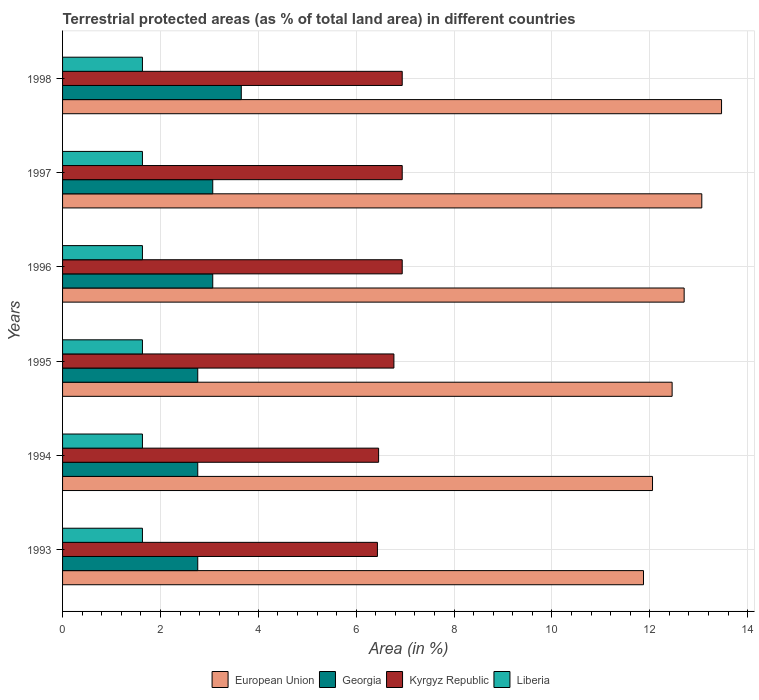How many different coloured bars are there?
Provide a succinct answer. 4. Are the number of bars per tick equal to the number of legend labels?
Offer a terse response. Yes. In how many cases, is the number of bars for a given year not equal to the number of legend labels?
Provide a succinct answer. 0. What is the percentage of terrestrial protected land in European Union in 1996?
Give a very brief answer. 12.7. Across all years, what is the maximum percentage of terrestrial protected land in Georgia?
Keep it short and to the point. 3.65. Across all years, what is the minimum percentage of terrestrial protected land in Georgia?
Your answer should be very brief. 2.76. In which year was the percentage of terrestrial protected land in Georgia maximum?
Give a very brief answer. 1998. What is the total percentage of terrestrial protected land in Kyrgyz Republic in the graph?
Provide a succinct answer. 40.49. What is the difference between the percentage of terrestrial protected land in European Union in 1996 and that in 1997?
Offer a terse response. -0.36. What is the difference between the percentage of terrestrial protected land in Liberia in 1993 and the percentage of terrestrial protected land in Kyrgyz Republic in 1997?
Ensure brevity in your answer.  -5.31. What is the average percentage of terrestrial protected land in Liberia per year?
Ensure brevity in your answer.  1.63. In the year 1996, what is the difference between the percentage of terrestrial protected land in European Union and percentage of terrestrial protected land in Liberia?
Keep it short and to the point. 11.07. In how many years, is the percentage of terrestrial protected land in Kyrgyz Republic greater than 2.4 %?
Ensure brevity in your answer.  6. What is the ratio of the percentage of terrestrial protected land in Kyrgyz Republic in 1994 to that in 1997?
Your answer should be very brief. 0.93. What is the difference between the highest and the second highest percentage of terrestrial protected land in Kyrgyz Republic?
Ensure brevity in your answer.  0. What is the difference between the highest and the lowest percentage of terrestrial protected land in Kyrgyz Republic?
Ensure brevity in your answer.  0.51. Is the sum of the percentage of terrestrial protected land in Liberia in 1994 and 1995 greater than the maximum percentage of terrestrial protected land in Georgia across all years?
Make the answer very short. No. What does the 1st bar from the top in 1998 represents?
Your answer should be very brief. Liberia. How many bars are there?
Provide a short and direct response. 24. Are all the bars in the graph horizontal?
Make the answer very short. Yes. What is the difference between two consecutive major ticks on the X-axis?
Your answer should be very brief. 2. Are the values on the major ticks of X-axis written in scientific E-notation?
Make the answer very short. No. Does the graph contain any zero values?
Your answer should be very brief. No. How many legend labels are there?
Your response must be concise. 4. What is the title of the graph?
Your answer should be very brief. Terrestrial protected areas (as % of total land area) in different countries. What is the label or title of the X-axis?
Offer a terse response. Area (in %). What is the label or title of the Y-axis?
Offer a very short reply. Years. What is the Area (in %) in European Union in 1993?
Your answer should be compact. 11.87. What is the Area (in %) in Georgia in 1993?
Your answer should be compact. 2.76. What is the Area (in %) in Kyrgyz Republic in 1993?
Ensure brevity in your answer.  6.43. What is the Area (in %) of Liberia in 1993?
Your answer should be compact. 1.63. What is the Area (in %) in European Union in 1994?
Keep it short and to the point. 12.06. What is the Area (in %) in Georgia in 1994?
Your response must be concise. 2.76. What is the Area (in %) in Kyrgyz Republic in 1994?
Ensure brevity in your answer.  6.46. What is the Area (in %) of Liberia in 1994?
Your answer should be compact. 1.63. What is the Area (in %) of European Union in 1995?
Your answer should be compact. 12.46. What is the Area (in %) in Georgia in 1995?
Provide a succinct answer. 2.76. What is the Area (in %) in Kyrgyz Republic in 1995?
Provide a short and direct response. 6.77. What is the Area (in %) in Liberia in 1995?
Ensure brevity in your answer.  1.63. What is the Area (in %) of European Union in 1996?
Make the answer very short. 12.7. What is the Area (in %) of Georgia in 1996?
Provide a succinct answer. 3.07. What is the Area (in %) in Kyrgyz Republic in 1996?
Make the answer very short. 6.94. What is the Area (in %) in Liberia in 1996?
Offer a terse response. 1.63. What is the Area (in %) in European Union in 1997?
Offer a terse response. 13.06. What is the Area (in %) of Georgia in 1997?
Keep it short and to the point. 3.07. What is the Area (in %) of Kyrgyz Republic in 1997?
Provide a short and direct response. 6.94. What is the Area (in %) in Liberia in 1997?
Offer a terse response. 1.63. What is the Area (in %) in European Union in 1998?
Keep it short and to the point. 13.47. What is the Area (in %) in Georgia in 1998?
Your answer should be very brief. 3.65. What is the Area (in %) of Kyrgyz Republic in 1998?
Offer a terse response. 6.94. What is the Area (in %) in Liberia in 1998?
Make the answer very short. 1.63. Across all years, what is the maximum Area (in %) in European Union?
Offer a terse response. 13.47. Across all years, what is the maximum Area (in %) in Georgia?
Provide a succinct answer. 3.65. Across all years, what is the maximum Area (in %) of Kyrgyz Republic?
Provide a short and direct response. 6.94. Across all years, what is the maximum Area (in %) in Liberia?
Your answer should be compact. 1.63. Across all years, what is the minimum Area (in %) in European Union?
Your response must be concise. 11.87. Across all years, what is the minimum Area (in %) in Georgia?
Offer a very short reply. 2.76. Across all years, what is the minimum Area (in %) of Kyrgyz Republic?
Give a very brief answer. 6.43. Across all years, what is the minimum Area (in %) in Liberia?
Your answer should be compact. 1.63. What is the total Area (in %) in European Union in the graph?
Make the answer very short. 75.62. What is the total Area (in %) in Georgia in the graph?
Your answer should be compact. 18.08. What is the total Area (in %) of Kyrgyz Republic in the graph?
Your answer should be compact. 40.49. What is the total Area (in %) in Liberia in the graph?
Provide a succinct answer. 9.79. What is the difference between the Area (in %) of European Union in 1993 and that in 1994?
Provide a short and direct response. -0.18. What is the difference between the Area (in %) of Kyrgyz Republic in 1993 and that in 1994?
Your answer should be very brief. -0.02. What is the difference between the Area (in %) of European Union in 1993 and that in 1995?
Offer a terse response. -0.59. What is the difference between the Area (in %) of Georgia in 1993 and that in 1995?
Your response must be concise. 0. What is the difference between the Area (in %) in Kyrgyz Republic in 1993 and that in 1995?
Your response must be concise. -0.34. What is the difference between the Area (in %) in European Union in 1993 and that in 1996?
Offer a terse response. -0.83. What is the difference between the Area (in %) of Georgia in 1993 and that in 1996?
Give a very brief answer. -0.31. What is the difference between the Area (in %) of Kyrgyz Republic in 1993 and that in 1996?
Ensure brevity in your answer.  -0.51. What is the difference between the Area (in %) of European Union in 1993 and that in 1997?
Your response must be concise. -1.19. What is the difference between the Area (in %) in Georgia in 1993 and that in 1997?
Your answer should be compact. -0.31. What is the difference between the Area (in %) in Kyrgyz Republic in 1993 and that in 1997?
Ensure brevity in your answer.  -0.51. What is the difference between the Area (in %) in Liberia in 1993 and that in 1997?
Provide a short and direct response. 0. What is the difference between the Area (in %) of European Union in 1993 and that in 1998?
Offer a very short reply. -1.6. What is the difference between the Area (in %) in Georgia in 1993 and that in 1998?
Make the answer very short. -0.89. What is the difference between the Area (in %) of Kyrgyz Republic in 1993 and that in 1998?
Make the answer very short. -0.51. What is the difference between the Area (in %) of Liberia in 1993 and that in 1998?
Your answer should be very brief. 0. What is the difference between the Area (in %) of European Union in 1994 and that in 1995?
Your answer should be very brief. -0.4. What is the difference between the Area (in %) in Georgia in 1994 and that in 1995?
Offer a terse response. 0. What is the difference between the Area (in %) of Kyrgyz Republic in 1994 and that in 1995?
Keep it short and to the point. -0.31. What is the difference between the Area (in %) in European Union in 1994 and that in 1996?
Your answer should be compact. -0.65. What is the difference between the Area (in %) in Georgia in 1994 and that in 1996?
Keep it short and to the point. -0.31. What is the difference between the Area (in %) of Kyrgyz Republic in 1994 and that in 1996?
Ensure brevity in your answer.  -0.48. What is the difference between the Area (in %) in European Union in 1994 and that in 1997?
Offer a terse response. -1.01. What is the difference between the Area (in %) of Georgia in 1994 and that in 1997?
Ensure brevity in your answer.  -0.31. What is the difference between the Area (in %) of Kyrgyz Republic in 1994 and that in 1997?
Your response must be concise. -0.48. What is the difference between the Area (in %) of Liberia in 1994 and that in 1997?
Offer a terse response. 0. What is the difference between the Area (in %) in European Union in 1994 and that in 1998?
Offer a terse response. -1.41. What is the difference between the Area (in %) of Georgia in 1994 and that in 1998?
Offer a very short reply. -0.89. What is the difference between the Area (in %) in Kyrgyz Republic in 1994 and that in 1998?
Your answer should be compact. -0.48. What is the difference between the Area (in %) of Liberia in 1994 and that in 1998?
Ensure brevity in your answer.  0. What is the difference between the Area (in %) of European Union in 1995 and that in 1996?
Make the answer very short. -0.25. What is the difference between the Area (in %) in Georgia in 1995 and that in 1996?
Ensure brevity in your answer.  -0.31. What is the difference between the Area (in %) of Kyrgyz Republic in 1995 and that in 1996?
Offer a very short reply. -0.17. What is the difference between the Area (in %) in Liberia in 1995 and that in 1996?
Make the answer very short. 0. What is the difference between the Area (in %) in European Union in 1995 and that in 1997?
Your answer should be very brief. -0.61. What is the difference between the Area (in %) in Georgia in 1995 and that in 1997?
Make the answer very short. -0.31. What is the difference between the Area (in %) in Kyrgyz Republic in 1995 and that in 1997?
Give a very brief answer. -0.17. What is the difference between the Area (in %) in European Union in 1995 and that in 1998?
Provide a succinct answer. -1.01. What is the difference between the Area (in %) in Georgia in 1995 and that in 1998?
Offer a very short reply. -0.89. What is the difference between the Area (in %) in Kyrgyz Republic in 1995 and that in 1998?
Provide a short and direct response. -0.17. What is the difference between the Area (in %) of Liberia in 1995 and that in 1998?
Your answer should be compact. 0. What is the difference between the Area (in %) of European Union in 1996 and that in 1997?
Your response must be concise. -0.36. What is the difference between the Area (in %) in Georgia in 1996 and that in 1997?
Your response must be concise. 0. What is the difference between the Area (in %) in Kyrgyz Republic in 1996 and that in 1997?
Provide a succinct answer. 0. What is the difference between the Area (in %) of Liberia in 1996 and that in 1997?
Offer a very short reply. 0. What is the difference between the Area (in %) of European Union in 1996 and that in 1998?
Your response must be concise. -0.76. What is the difference between the Area (in %) in Georgia in 1996 and that in 1998?
Offer a terse response. -0.58. What is the difference between the Area (in %) in Kyrgyz Republic in 1996 and that in 1998?
Your response must be concise. 0. What is the difference between the Area (in %) in European Union in 1997 and that in 1998?
Ensure brevity in your answer.  -0.4. What is the difference between the Area (in %) in Georgia in 1997 and that in 1998?
Provide a succinct answer. -0.58. What is the difference between the Area (in %) of Liberia in 1997 and that in 1998?
Make the answer very short. 0. What is the difference between the Area (in %) in European Union in 1993 and the Area (in %) in Georgia in 1994?
Make the answer very short. 9.11. What is the difference between the Area (in %) of European Union in 1993 and the Area (in %) of Kyrgyz Republic in 1994?
Ensure brevity in your answer.  5.41. What is the difference between the Area (in %) of European Union in 1993 and the Area (in %) of Liberia in 1994?
Offer a very short reply. 10.24. What is the difference between the Area (in %) of Georgia in 1993 and the Area (in %) of Kyrgyz Republic in 1994?
Keep it short and to the point. -3.7. What is the difference between the Area (in %) in Georgia in 1993 and the Area (in %) in Liberia in 1994?
Your answer should be very brief. 1.13. What is the difference between the Area (in %) in Kyrgyz Republic in 1993 and the Area (in %) in Liberia in 1994?
Offer a very short reply. 4.8. What is the difference between the Area (in %) in European Union in 1993 and the Area (in %) in Georgia in 1995?
Offer a very short reply. 9.11. What is the difference between the Area (in %) of European Union in 1993 and the Area (in %) of Kyrgyz Republic in 1995?
Give a very brief answer. 5.1. What is the difference between the Area (in %) in European Union in 1993 and the Area (in %) in Liberia in 1995?
Your answer should be compact. 10.24. What is the difference between the Area (in %) of Georgia in 1993 and the Area (in %) of Kyrgyz Republic in 1995?
Provide a succinct answer. -4.01. What is the difference between the Area (in %) of Georgia in 1993 and the Area (in %) of Liberia in 1995?
Give a very brief answer. 1.13. What is the difference between the Area (in %) in Kyrgyz Republic in 1993 and the Area (in %) in Liberia in 1995?
Provide a short and direct response. 4.8. What is the difference between the Area (in %) of European Union in 1993 and the Area (in %) of Georgia in 1996?
Your answer should be very brief. 8.8. What is the difference between the Area (in %) in European Union in 1993 and the Area (in %) in Kyrgyz Republic in 1996?
Your answer should be compact. 4.93. What is the difference between the Area (in %) in European Union in 1993 and the Area (in %) in Liberia in 1996?
Ensure brevity in your answer.  10.24. What is the difference between the Area (in %) in Georgia in 1993 and the Area (in %) in Kyrgyz Republic in 1996?
Your response must be concise. -4.18. What is the difference between the Area (in %) in Georgia in 1993 and the Area (in %) in Liberia in 1996?
Your answer should be very brief. 1.13. What is the difference between the Area (in %) in Kyrgyz Republic in 1993 and the Area (in %) in Liberia in 1996?
Provide a short and direct response. 4.8. What is the difference between the Area (in %) of European Union in 1993 and the Area (in %) of Georgia in 1997?
Make the answer very short. 8.8. What is the difference between the Area (in %) of European Union in 1993 and the Area (in %) of Kyrgyz Republic in 1997?
Make the answer very short. 4.93. What is the difference between the Area (in %) in European Union in 1993 and the Area (in %) in Liberia in 1997?
Your answer should be compact. 10.24. What is the difference between the Area (in %) of Georgia in 1993 and the Area (in %) of Kyrgyz Republic in 1997?
Give a very brief answer. -4.18. What is the difference between the Area (in %) of Georgia in 1993 and the Area (in %) of Liberia in 1997?
Keep it short and to the point. 1.13. What is the difference between the Area (in %) of Kyrgyz Republic in 1993 and the Area (in %) of Liberia in 1997?
Keep it short and to the point. 4.8. What is the difference between the Area (in %) of European Union in 1993 and the Area (in %) of Georgia in 1998?
Offer a very short reply. 8.22. What is the difference between the Area (in %) of European Union in 1993 and the Area (in %) of Kyrgyz Republic in 1998?
Make the answer very short. 4.93. What is the difference between the Area (in %) in European Union in 1993 and the Area (in %) in Liberia in 1998?
Provide a succinct answer. 10.24. What is the difference between the Area (in %) of Georgia in 1993 and the Area (in %) of Kyrgyz Republic in 1998?
Provide a short and direct response. -4.18. What is the difference between the Area (in %) of Georgia in 1993 and the Area (in %) of Liberia in 1998?
Provide a short and direct response. 1.13. What is the difference between the Area (in %) in Kyrgyz Republic in 1993 and the Area (in %) in Liberia in 1998?
Ensure brevity in your answer.  4.8. What is the difference between the Area (in %) of European Union in 1994 and the Area (in %) of Georgia in 1995?
Your answer should be very brief. 9.29. What is the difference between the Area (in %) of European Union in 1994 and the Area (in %) of Kyrgyz Republic in 1995?
Your answer should be very brief. 5.29. What is the difference between the Area (in %) in European Union in 1994 and the Area (in %) in Liberia in 1995?
Make the answer very short. 10.42. What is the difference between the Area (in %) of Georgia in 1994 and the Area (in %) of Kyrgyz Republic in 1995?
Make the answer very short. -4.01. What is the difference between the Area (in %) in Georgia in 1994 and the Area (in %) in Liberia in 1995?
Provide a succinct answer. 1.13. What is the difference between the Area (in %) in Kyrgyz Republic in 1994 and the Area (in %) in Liberia in 1995?
Offer a terse response. 4.83. What is the difference between the Area (in %) in European Union in 1994 and the Area (in %) in Georgia in 1996?
Give a very brief answer. 8.99. What is the difference between the Area (in %) in European Union in 1994 and the Area (in %) in Kyrgyz Republic in 1996?
Make the answer very short. 5.12. What is the difference between the Area (in %) of European Union in 1994 and the Area (in %) of Liberia in 1996?
Your answer should be compact. 10.42. What is the difference between the Area (in %) in Georgia in 1994 and the Area (in %) in Kyrgyz Republic in 1996?
Your answer should be compact. -4.18. What is the difference between the Area (in %) in Georgia in 1994 and the Area (in %) in Liberia in 1996?
Offer a terse response. 1.13. What is the difference between the Area (in %) of Kyrgyz Republic in 1994 and the Area (in %) of Liberia in 1996?
Offer a terse response. 4.83. What is the difference between the Area (in %) of European Union in 1994 and the Area (in %) of Georgia in 1997?
Your answer should be very brief. 8.99. What is the difference between the Area (in %) of European Union in 1994 and the Area (in %) of Kyrgyz Republic in 1997?
Provide a succinct answer. 5.12. What is the difference between the Area (in %) in European Union in 1994 and the Area (in %) in Liberia in 1997?
Provide a short and direct response. 10.42. What is the difference between the Area (in %) of Georgia in 1994 and the Area (in %) of Kyrgyz Republic in 1997?
Make the answer very short. -4.18. What is the difference between the Area (in %) in Georgia in 1994 and the Area (in %) in Liberia in 1997?
Your answer should be compact. 1.13. What is the difference between the Area (in %) in Kyrgyz Republic in 1994 and the Area (in %) in Liberia in 1997?
Provide a short and direct response. 4.83. What is the difference between the Area (in %) of European Union in 1994 and the Area (in %) of Georgia in 1998?
Offer a terse response. 8.4. What is the difference between the Area (in %) of European Union in 1994 and the Area (in %) of Kyrgyz Republic in 1998?
Your response must be concise. 5.12. What is the difference between the Area (in %) in European Union in 1994 and the Area (in %) in Liberia in 1998?
Ensure brevity in your answer.  10.42. What is the difference between the Area (in %) of Georgia in 1994 and the Area (in %) of Kyrgyz Republic in 1998?
Ensure brevity in your answer.  -4.18. What is the difference between the Area (in %) in Georgia in 1994 and the Area (in %) in Liberia in 1998?
Offer a very short reply. 1.13. What is the difference between the Area (in %) of Kyrgyz Republic in 1994 and the Area (in %) of Liberia in 1998?
Make the answer very short. 4.83. What is the difference between the Area (in %) in European Union in 1995 and the Area (in %) in Georgia in 1996?
Keep it short and to the point. 9.39. What is the difference between the Area (in %) in European Union in 1995 and the Area (in %) in Kyrgyz Republic in 1996?
Ensure brevity in your answer.  5.52. What is the difference between the Area (in %) in European Union in 1995 and the Area (in %) in Liberia in 1996?
Provide a short and direct response. 10.83. What is the difference between the Area (in %) in Georgia in 1995 and the Area (in %) in Kyrgyz Republic in 1996?
Provide a succinct answer. -4.18. What is the difference between the Area (in %) of Georgia in 1995 and the Area (in %) of Liberia in 1996?
Offer a terse response. 1.13. What is the difference between the Area (in %) in Kyrgyz Republic in 1995 and the Area (in %) in Liberia in 1996?
Offer a very short reply. 5.14. What is the difference between the Area (in %) in European Union in 1995 and the Area (in %) in Georgia in 1997?
Your answer should be very brief. 9.39. What is the difference between the Area (in %) in European Union in 1995 and the Area (in %) in Kyrgyz Republic in 1997?
Offer a terse response. 5.52. What is the difference between the Area (in %) in European Union in 1995 and the Area (in %) in Liberia in 1997?
Your answer should be very brief. 10.83. What is the difference between the Area (in %) of Georgia in 1995 and the Area (in %) of Kyrgyz Republic in 1997?
Provide a succinct answer. -4.18. What is the difference between the Area (in %) of Georgia in 1995 and the Area (in %) of Liberia in 1997?
Your answer should be compact. 1.13. What is the difference between the Area (in %) of Kyrgyz Republic in 1995 and the Area (in %) of Liberia in 1997?
Give a very brief answer. 5.14. What is the difference between the Area (in %) of European Union in 1995 and the Area (in %) of Georgia in 1998?
Offer a very short reply. 8.81. What is the difference between the Area (in %) of European Union in 1995 and the Area (in %) of Kyrgyz Republic in 1998?
Keep it short and to the point. 5.52. What is the difference between the Area (in %) of European Union in 1995 and the Area (in %) of Liberia in 1998?
Provide a succinct answer. 10.83. What is the difference between the Area (in %) in Georgia in 1995 and the Area (in %) in Kyrgyz Republic in 1998?
Keep it short and to the point. -4.18. What is the difference between the Area (in %) in Georgia in 1995 and the Area (in %) in Liberia in 1998?
Provide a succinct answer. 1.13. What is the difference between the Area (in %) of Kyrgyz Republic in 1995 and the Area (in %) of Liberia in 1998?
Offer a very short reply. 5.14. What is the difference between the Area (in %) of European Union in 1996 and the Area (in %) of Georgia in 1997?
Ensure brevity in your answer.  9.63. What is the difference between the Area (in %) of European Union in 1996 and the Area (in %) of Kyrgyz Republic in 1997?
Your answer should be very brief. 5.76. What is the difference between the Area (in %) in European Union in 1996 and the Area (in %) in Liberia in 1997?
Keep it short and to the point. 11.07. What is the difference between the Area (in %) of Georgia in 1996 and the Area (in %) of Kyrgyz Republic in 1997?
Give a very brief answer. -3.87. What is the difference between the Area (in %) of Georgia in 1996 and the Area (in %) of Liberia in 1997?
Your response must be concise. 1.44. What is the difference between the Area (in %) of Kyrgyz Republic in 1996 and the Area (in %) of Liberia in 1997?
Keep it short and to the point. 5.31. What is the difference between the Area (in %) in European Union in 1996 and the Area (in %) in Georgia in 1998?
Offer a very short reply. 9.05. What is the difference between the Area (in %) of European Union in 1996 and the Area (in %) of Kyrgyz Republic in 1998?
Provide a short and direct response. 5.76. What is the difference between the Area (in %) in European Union in 1996 and the Area (in %) in Liberia in 1998?
Give a very brief answer. 11.07. What is the difference between the Area (in %) in Georgia in 1996 and the Area (in %) in Kyrgyz Republic in 1998?
Your answer should be very brief. -3.87. What is the difference between the Area (in %) of Georgia in 1996 and the Area (in %) of Liberia in 1998?
Keep it short and to the point. 1.44. What is the difference between the Area (in %) in Kyrgyz Republic in 1996 and the Area (in %) in Liberia in 1998?
Your answer should be very brief. 5.31. What is the difference between the Area (in %) in European Union in 1997 and the Area (in %) in Georgia in 1998?
Your answer should be compact. 9.41. What is the difference between the Area (in %) of European Union in 1997 and the Area (in %) of Kyrgyz Republic in 1998?
Your answer should be compact. 6.12. What is the difference between the Area (in %) in European Union in 1997 and the Area (in %) in Liberia in 1998?
Make the answer very short. 11.43. What is the difference between the Area (in %) of Georgia in 1997 and the Area (in %) of Kyrgyz Republic in 1998?
Give a very brief answer. -3.87. What is the difference between the Area (in %) in Georgia in 1997 and the Area (in %) in Liberia in 1998?
Offer a very short reply. 1.44. What is the difference between the Area (in %) in Kyrgyz Republic in 1997 and the Area (in %) in Liberia in 1998?
Provide a succinct answer. 5.31. What is the average Area (in %) in European Union per year?
Provide a short and direct response. 12.6. What is the average Area (in %) of Georgia per year?
Your answer should be very brief. 3.01. What is the average Area (in %) of Kyrgyz Republic per year?
Your response must be concise. 6.75. What is the average Area (in %) in Liberia per year?
Ensure brevity in your answer.  1.63. In the year 1993, what is the difference between the Area (in %) in European Union and Area (in %) in Georgia?
Offer a terse response. 9.11. In the year 1993, what is the difference between the Area (in %) in European Union and Area (in %) in Kyrgyz Republic?
Offer a very short reply. 5.44. In the year 1993, what is the difference between the Area (in %) of European Union and Area (in %) of Liberia?
Make the answer very short. 10.24. In the year 1993, what is the difference between the Area (in %) in Georgia and Area (in %) in Kyrgyz Republic?
Keep it short and to the point. -3.67. In the year 1993, what is the difference between the Area (in %) of Georgia and Area (in %) of Liberia?
Your answer should be compact. 1.13. In the year 1993, what is the difference between the Area (in %) in Kyrgyz Republic and Area (in %) in Liberia?
Offer a very short reply. 4.8. In the year 1994, what is the difference between the Area (in %) of European Union and Area (in %) of Georgia?
Provide a short and direct response. 9.29. In the year 1994, what is the difference between the Area (in %) of European Union and Area (in %) of Kyrgyz Republic?
Make the answer very short. 5.6. In the year 1994, what is the difference between the Area (in %) in European Union and Area (in %) in Liberia?
Offer a very short reply. 10.42. In the year 1994, what is the difference between the Area (in %) of Georgia and Area (in %) of Kyrgyz Republic?
Keep it short and to the point. -3.7. In the year 1994, what is the difference between the Area (in %) of Georgia and Area (in %) of Liberia?
Your response must be concise. 1.13. In the year 1994, what is the difference between the Area (in %) in Kyrgyz Republic and Area (in %) in Liberia?
Your response must be concise. 4.83. In the year 1995, what is the difference between the Area (in %) of European Union and Area (in %) of Georgia?
Your response must be concise. 9.7. In the year 1995, what is the difference between the Area (in %) in European Union and Area (in %) in Kyrgyz Republic?
Your answer should be very brief. 5.69. In the year 1995, what is the difference between the Area (in %) in European Union and Area (in %) in Liberia?
Ensure brevity in your answer.  10.83. In the year 1995, what is the difference between the Area (in %) in Georgia and Area (in %) in Kyrgyz Republic?
Your answer should be very brief. -4.01. In the year 1995, what is the difference between the Area (in %) of Georgia and Area (in %) of Liberia?
Ensure brevity in your answer.  1.13. In the year 1995, what is the difference between the Area (in %) of Kyrgyz Republic and Area (in %) of Liberia?
Provide a succinct answer. 5.14. In the year 1996, what is the difference between the Area (in %) in European Union and Area (in %) in Georgia?
Ensure brevity in your answer.  9.63. In the year 1996, what is the difference between the Area (in %) in European Union and Area (in %) in Kyrgyz Republic?
Provide a short and direct response. 5.76. In the year 1996, what is the difference between the Area (in %) in European Union and Area (in %) in Liberia?
Your answer should be very brief. 11.07. In the year 1996, what is the difference between the Area (in %) in Georgia and Area (in %) in Kyrgyz Republic?
Provide a succinct answer. -3.87. In the year 1996, what is the difference between the Area (in %) in Georgia and Area (in %) in Liberia?
Offer a very short reply. 1.44. In the year 1996, what is the difference between the Area (in %) of Kyrgyz Republic and Area (in %) of Liberia?
Offer a terse response. 5.31. In the year 1997, what is the difference between the Area (in %) of European Union and Area (in %) of Georgia?
Your response must be concise. 10. In the year 1997, what is the difference between the Area (in %) in European Union and Area (in %) in Kyrgyz Republic?
Provide a succinct answer. 6.12. In the year 1997, what is the difference between the Area (in %) in European Union and Area (in %) in Liberia?
Provide a succinct answer. 11.43. In the year 1997, what is the difference between the Area (in %) of Georgia and Area (in %) of Kyrgyz Republic?
Make the answer very short. -3.87. In the year 1997, what is the difference between the Area (in %) in Georgia and Area (in %) in Liberia?
Your answer should be very brief. 1.44. In the year 1997, what is the difference between the Area (in %) of Kyrgyz Republic and Area (in %) of Liberia?
Ensure brevity in your answer.  5.31. In the year 1998, what is the difference between the Area (in %) of European Union and Area (in %) of Georgia?
Provide a short and direct response. 9.82. In the year 1998, what is the difference between the Area (in %) of European Union and Area (in %) of Kyrgyz Republic?
Your response must be concise. 6.53. In the year 1998, what is the difference between the Area (in %) of European Union and Area (in %) of Liberia?
Your answer should be very brief. 11.84. In the year 1998, what is the difference between the Area (in %) of Georgia and Area (in %) of Kyrgyz Republic?
Keep it short and to the point. -3.29. In the year 1998, what is the difference between the Area (in %) of Georgia and Area (in %) of Liberia?
Give a very brief answer. 2.02. In the year 1998, what is the difference between the Area (in %) in Kyrgyz Republic and Area (in %) in Liberia?
Ensure brevity in your answer.  5.31. What is the ratio of the Area (in %) of European Union in 1993 to that in 1994?
Make the answer very short. 0.98. What is the ratio of the Area (in %) of Kyrgyz Republic in 1993 to that in 1994?
Your answer should be very brief. 1. What is the ratio of the Area (in %) of European Union in 1993 to that in 1995?
Your answer should be very brief. 0.95. What is the ratio of the Area (in %) in Georgia in 1993 to that in 1995?
Your answer should be compact. 1. What is the ratio of the Area (in %) of Kyrgyz Republic in 1993 to that in 1995?
Ensure brevity in your answer.  0.95. What is the ratio of the Area (in %) of Liberia in 1993 to that in 1995?
Provide a short and direct response. 1. What is the ratio of the Area (in %) in European Union in 1993 to that in 1996?
Ensure brevity in your answer.  0.93. What is the ratio of the Area (in %) of Georgia in 1993 to that in 1996?
Your answer should be compact. 0.9. What is the ratio of the Area (in %) of Kyrgyz Republic in 1993 to that in 1996?
Offer a terse response. 0.93. What is the ratio of the Area (in %) in Liberia in 1993 to that in 1996?
Your response must be concise. 1. What is the ratio of the Area (in %) of European Union in 1993 to that in 1997?
Your answer should be compact. 0.91. What is the ratio of the Area (in %) in Georgia in 1993 to that in 1997?
Provide a succinct answer. 0.9. What is the ratio of the Area (in %) in Kyrgyz Republic in 1993 to that in 1997?
Make the answer very short. 0.93. What is the ratio of the Area (in %) of Liberia in 1993 to that in 1997?
Your answer should be compact. 1. What is the ratio of the Area (in %) in European Union in 1993 to that in 1998?
Your answer should be compact. 0.88. What is the ratio of the Area (in %) of Georgia in 1993 to that in 1998?
Offer a very short reply. 0.76. What is the ratio of the Area (in %) in Kyrgyz Republic in 1993 to that in 1998?
Your answer should be compact. 0.93. What is the ratio of the Area (in %) of Liberia in 1993 to that in 1998?
Ensure brevity in your answer.  1. What is the ratio of the Area (in %) of European Union in 1994 to that in 1995?
Your answer should be very brief. 0.97. What is the ratio of the Area (in %) in Kyrgyz Republic in 1994 to that in 1995?
Give a very brief answer. 0.95. What is the ratio of the Area (in %) in Liberia in 1994 to that in 1995?
Your answer should be compact. 1. What is the ratio of the Area (in %) in European Union in 1994 to that in 1996?
Give a very brief answer. 0.95. What is the ratio of the Area (in %) of Georgia in 1994 to that in 1996?
Your answer should be very brief. 0.9. What is the ratio of the Area (in %) of Kyrgyz Republic in 1994 to that in 1996?
Your response must be concise. 0.93. What is the ratio of the Area (in %) in Liberia in 1994 to that in 1996?
Provide a short and direct response. 1. What is the ratio of the Area (in %) in European Union in 1994 to that in 1997?
Offer a very short reply. 0.92. What is the ratio of the Area (in %) in Georgia in 1994 to that in 1997?
Make the answer very short. 0.9. What is the ratio of the Area (in %) of Kyrgyz Republic in 1994 to that in 1997?
Provide a succinct answer. 0.93. What is the ratio of the Area (in %) in European Union in 1994 to that in 1998?
Ensure brevity in your answer.  0.9. What is the ratio of the Area (in %) in Georgia in 1994 to that in 1998?
Give a very brief answer. 0.76. What is the ratio of the Area (in %) of Kyrgyz Republic in 1994 to that in 1998?
Keep it short and to the point. 0.93. What is the ratio of the Area (in %) in Liberia in 1994 to that in 1998?
Give a very brief answer. 1. What is the ratio of the Area (in %) of European Union in 1995 to that in 1996?
Your answer should be compact. 0.98. What is the ratio of the Area (in %) in Georgia in 1995 to that in 1996?
Your answer should be very brief. 0.9. What is the ratio of the Area (in %) in Kyrgyz Republic in 1995 to that in 1996?
Your answer should be compact. 0.98. What is the ratio of the Area (in %) in European Union in 1995 to that in 1997?
Make the answer very short. 0.95. What is the ratio of the Area (in %) of Georgia in 1995 to that in 1997?
Ensure brevity in your answer.  0.9. What is the ratio of the Area (in %) of Kyrgyz Republic in 1995 to that in 1997?
Keep it short and to the point. 0.98. What is the ratio of the Area (in %) of Liberia in 1995 to that in 1997?
Ensure brevity in your answer.  1. What is the ratio of the Area (in %) of European Union in 1995 to that in 1998?
Provide a succinct answer. 0.93. What is the ratio of the Area (in %) of Georgia in 1995 to that in 1998?
Make the answer very short. 0.76. What is the ratio of the Area (in %) in Kyrgyz Republic in 1995 to that in 1998?
Your answer should be compact. 0.98. What is the ratio of the Area (in %) in Liberia in 1995 to that in 1998?
Your answer should be very brief. 1. What is the ratio of the Area (in %) in European Union in 1996 to that in 1997?
Make the answer very short. 0.97. What is the ratio of the Area (in %) in Kyrgyz Republic in 1996 to that in 1997?
Provide a succinct answer. 1. What is the ratio of the Area (in %) in Liberia in 1996 to that in 1997?
Provide a succinct answer. 1. What is the ratio of the Area (in %) of European Union in 1996 to that in 1998?
Provide a short and direct response. 0.94. What is the ratio of the Area (in %) in Georgia in 1996 to that in 1998?
Your answer should be compact. 0.84. What is the ratio of the Area (in %) of Kyrgyz Republic in 1996 to that in 1998?
Give a very brief answer. 1. What is the ratio of the Area (in %) in Liberia in 1996 to that in 1998?
Offer a very short reply. 1. What is the ratio of the Area (in %) in European Union in 1997 to that in 1998?
Offer a terse response. 0.97. What is the ratio of the Area (in %) of Georgia in 1997 to that in 1998?
Your answer should be very brief. 0.84. What is the ratio of the Area (in %) of Kyrgyz Republic in 1997 to that in 1998?
Your answer should be compact. 1. What is the difference between the highest and the second highest Area (in %) in European Union?
Make the answer very short. 0.4. What is the difference between the highest and the second highest Area (in %) in Georgia?
Ensure brevity in your answer.  0.58. What is the difference between the highest and the second highest Area (in %) of Kyrgyz Republic?
Keep it short and to the point. 0. What is the difference between the highest and the second highest Area (in %) in Liberia?
Provide a short and direct response. 0. What is the difference between the highest and the lowest Area (in %) in European Union?
Ensure brevity in your answer.  1.6. What is the difference between the highest and the lowest Area (in %) of Georgia?
Your answer should be very brief. 0.89. What is the difference between the highest and the lowest Area (in %) in Kyrgyz Republic?
Offer a terse response. 0.51. 